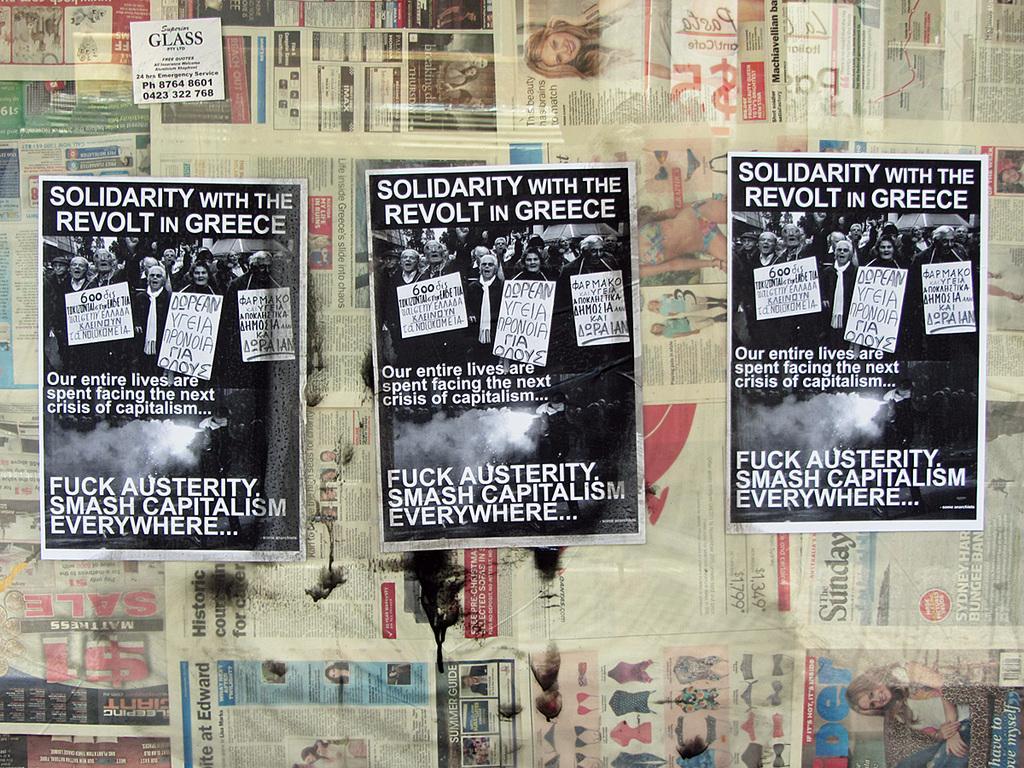Could you give a brief overview of what you see in this image? This image consists of many newspapers with images and text on them and in the middle of the image there are three posters with a few images and text on them. 